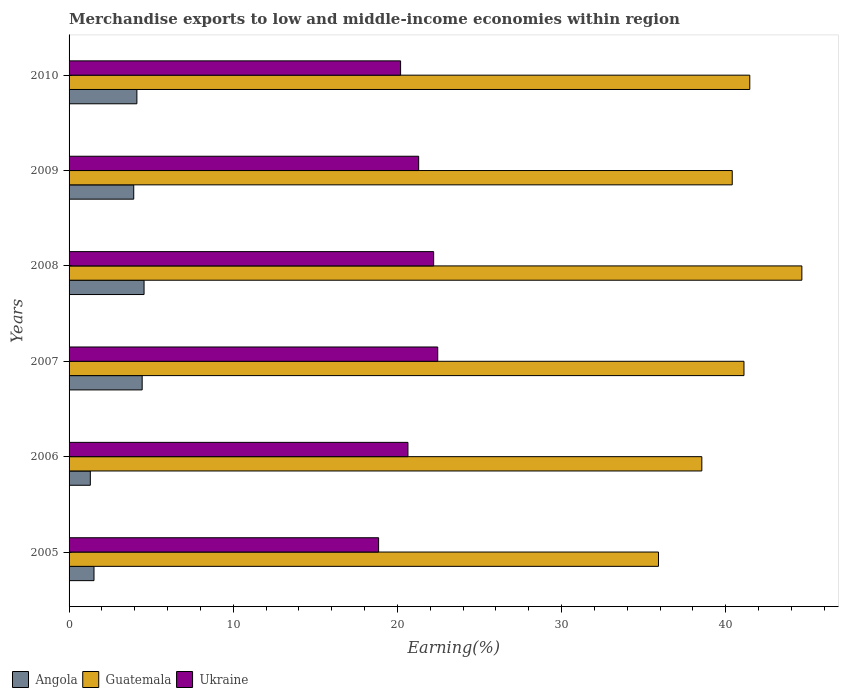Are the number of bars per tick equal to the number of legend labels?
Give a very brief answer. Yes. How many bars are there on the 3rd tick from the top?
Keep it short and to the point. 3. How many bars are there on the 2nd tick from the bottom?
Ensure brevity in your answer.  3. What is the label of the 2nd group of bars from the top?
Your answer should be very brief. 2009. What is the percentage of amount earned from merchandise exports in Angola in 2006?
Keep it short and to the point. 1.3. Across all years, what is the maximum percentage of amount earned from merchandise exports in Guatemala?
Give a very brief answer. 44.63. Across all years, what is the minimum percentage of amount earned from merchandise exports in Guatemala?
Provide a short and direct response. 35.9. In which year was the percentage of amount earned from merchandise exports in Angola maximum?
Your answer should be compact. 2008. In which year was the percentage of amount earned from merchandise exports in Angola minimum?
Ensure brevity in your answer.  2006. What is the total percentage of amount earned from merchandise exports in Guatemala in the graph?
Provide a succinct answer. 242.04. What is the difference between the percentage of amount earned from merchandise exports in Guatemala in 2005 and that in 2007?
Provide a succinct answer. -5.21. What is the difference between the percentage of amount earned from merchandise exports in Angola in 2006 and the percentage of amount earned from merchandise exports in Ukraine in 2009?
Provide a short and direct response. -20. What is the average percentage of amount earned from merchandise exports in Angola per year?
Ensure brevity in your answer.  3.32. In the year 2008, what is the difference between the percentage of amount earned from merchandise exports in Guatemala and percentage of amount earned from merchandise exports in Angola?
Your answer should be very brief. 40.07. What is the ratio of the percentage of amount earned from merchandise exports in Guatemala in 2005 to that in 2008?
Offer a terse response. 0.8. Is the percentage of amount earned from merchandise exports in Angola in 2007 less than that in 2010?
Offer a terse response. No. Is the difference between the percentage of amount earned from merchandise exports in Guatemala in 2005 and 2008 greater than the difference between the percentage of amount earned from merchandise exports in Angola in 2005 and 2008?
Offer a very short reply. No. What is the difference between the highest and the second highest percentage of amount earned from merchandise exports in Angola?
Offer a very short reply. 0.11. What is the difference between the highest and the lowest percentage of amount earned from merchandise exports in Ukraine?
Your answer should be very brief. 3.6. In how many years, is the percentage of amount earned from merchandise exports in Angola greater than the average percentage of amount earned from merchandise exports in Angola taken over all years?
Provide a succinct answer. 4. What does the 2nd bar from the top in 2008 represents?
Ensure brevity in your answer.  Guatemala. What does the 1st bar from the bottom in 2009 represents?
Make the answer very short. Angola. How many bars are there?
Your answer should be compact. 18. Are all the bars in the graph horizontal?
Your answer should be very brief. Yes. Does the graph contain any zero values?
Keep it short and to the point. No. Does the graph contain grids?
Offer a very short reply. No. Where does the legend appear in the graph?
Offer a very short reply. Bottom left. How are the legend labels stacked?
Your answer should be compact. Horizontal. What is the title of the graph?
Provide a short and direct response. Merchandise exports to low and middle-income economies within region. What is the label or title of the X-axis?
Your response must be concise. Earning(%). What is the Earning(%) in Angola in 2005?
Provide a succinct answer. 1.52. What is the Earning(%) of Guatemala in 2005?
Offer a very short reply. 35.9. What is the Earning(%) in Ukraine in 2005?
Your answer should be very brief. 18.85. What is the Earning(%) of Angola in 2006?
Provide a succinct answer. 1.3. What is the Earning(%) in Guatemala in 2006?
Make the answer very short. 38.54. What is the Earning(%) in Ukraine in 2006?
Your answer should be very brief. 20.64. What is the Earning(%) in Angola in 2007?
Your answer should be compact. 4.45. What is the Earning(%) of Guatemala in 2007?
Give a very brief answer. 41.11. What is the Earning(%) of Ukraine in 2007?
Offer a very short reply. 22.46. What is the Earning(%) in Angola in 2008?
Your answer should be compact. 4.57. What is the Earning(%) in Guatemala in 2008?
Offer a very short reply. 44.63. What is the Earning(%) in Ukraine in 2008?
Provide a short and direct response. 22.21. What is the Earning(%) in Angola in 2009?
Give a very brief answer. 3.94. What is the Earning(%) in Guatemala in 2009?
Offer a very short reply. 40.39. What is the Earning(%) in Ukraine in 2009?
Keep it short and to the point. 21.29. What is the Earning(%) in Angola in 2010?
Your response must be concise. 4.13. What is the Earning(%) of Guatemala in 2010?
Your response must be concise. 41.46. What is the Earning(%) in Ukraine in 2010?
Give a very brief answer. 20.19. Across all years, what is the maximum Earning(%) in Angola?
Keep it short and to the point. 4.57. Across all years, what is the maximum Earning(%) of Guatemala?
Provide a short and direct response. 44.63. Across all years, what is the maximum Earning(%) in Ukraine?
Ensure brevity in your answer.  22.46. Across all years, what is the minimum Earning(%) in Angola?
Provide a short and direct response. 1.3. Across all years, what is the minimum Earning(%) in Guatemala?
Your response must be concise. 35.9. Across all years, what is the minimum Earning(%) in Ukraine?
Your response must be concise. 18.85. What is the total Earning(%) of Angola in the graph?
Keep it short and to the point. 19.9. What is the total Earning(%) in Guatemala in the graph?
Offer a terse response. 242.03. What is the total Earning(%) of Ukraine in the graph?
Offer a very short reply. 125.64. What is the difference between the Earning(%) in Angola in 2005 and that in 2006?
Your answer should be very brief. 0.22. What is the difference between the Earning(%) in Guatemala in 2005 and that in 2006?
Your response must be concise. -2.64. What is the difference between the Earning(%) in Ukraine in 2005 and that in 2006?
Make the answer very short. -1.79. What is the difference between the Earning(%) of Angola in 2005 and that in 2007?
Offer a very short reply. -2.93. What is the difference between the Earning(%) in Guatemala in 2005 and that in 2007?
Your answer should be very brief. -5.21. What is the difference between the Earning(%) in Ukraine in 2005 and that in 2007?
Offer a terse response. -3.6. What is the difference between the Earning(%) in Angola in 2005 and that in 2008?
Make the answer very short. -3.05. What is the difference between the Earning(%) of Guatemala in 2005 and that in 2008?
Offer a terse response. -8.73. What is the difference between the Earning(%) in Ukraine in 2005 and that in 2008?
Provide a succinct answer. -3.35. What is the difference between the Earning(%) in Angola in 2005 and that in 2009?
Ensure brevity in your answer.  -2.42. What is the difference between the Earning(%) in Guatemala in 2005 and that in 2009?
Your response must be concise. -4.49. What is the difference between the Earning(%) in Ukraine in 2005 and that in 2009?
Your answer should be compact. -2.44. What is the difference between the Earning(%) in Angola in 2005 and that in 2010?
Make the answer very short. -2.61. What is the difference between the Earning(%) of Guatemala in 2005 and that in 2010?
Make the answer very short. -5.56. What is the difference between the Earning(%) of Ukraine in 2005 and that in 2010?
Ensure brevity in your answer.  -1.34. What is the difference between the Earning(%) in Angola in 2006 and that in 2007?
Provide a short and direct response. -3.16. What is the difference between the Earning(%) of Guatemala in 2006 and that in 2007?
Make the answer very short. -2.57. What is the difference between the Earning(%) of Ukraine in 2006 and that in 2007?
Provide a succinct answer. -1.81. What is the difference between the Earning(%) in Angola in 2006 and that in 2008?
Your response must be concise. -3.27. What is the difference between the Earning(%) in Guatemala in 2006 and that in 2008?
Make the answer very short. -6.09. What is the difference between the Earning(%) in Ukraine in 2006 and that in 2008?
Make the answer very short. -1.57. What is the difference between the Earning(%) of Angola in 2006 and that in 2009?
Provide a short and direct response. -2.64. What is the difference between the Earning(%) in Guatemala in 2006 and that in 2009?
Your response must be concise. -1.85. What is the difference between the Earning(%) of Ukraine in 2006 and that in 2009?
Your answer should be compact. -0.65. What is the difference between the Earning(%) in Angola in 2006 and that in 2010?
Make the answer very short. -2.84. What is the difference between the Earning(%) of Guatemala in 2006 and that in 2010?
Provide a short and direct response. -2.92. What is the difference between the Earning(%) in Ukraine in 2006 and that in 2010?
Keep it short and to the point. 0.45. What is the difference between the Earning(%) in Angola in 2007 and that in 2008?
Give a very brief answer. -0.11. What is the difference between the Earning(%) in Guatemala in 2007 and that in 2008?
Your answer should be very brief. -3.53. What is the difference between the Earning(%) of Ukraine in 2007 and that in 2008?
Provide a succinct answer. 0.25. What is the difference between the Earning(%) of Angola in 2007 and that in 2009?
Provide a short and direct response. 0.51. What is the difference between the Earning(%) of Guatemala in 2007 and that in 2009?
Make the answer very short. 0.71. What is the difference between the Earning(%) of Ukraine in 2007 and that in 2009?
Give a very brief answer. 1.16. What is the difference between the Earning(%) in Angola in 2007 and that in 2010?
Your response must be concise. 0.32. What is the difference between the Earning(%) of Guatemala in 2007 and that in 2010?
Give a very brief answer. -0.35. What is the difference between the Earning(%) in Ukraine in 2007 and that in 2010?
Provide a succinct answer. 2.26. What is the difference between the Earning(%) of Angola in 2008 and that in 2009?
Provide a succinct answer. 0.63. What is the difference between the Earning(%) of Guatemala in 2008 and that in 2009?
Keep it short and to the point. 4.24. What is the difference between the Earning(%) in Ukraine in 2008 and that in 2009?
Give a very brief answer. 0.91. What is the difference between the Earning(%) in Angola in 2008 and that in 2010?
Keep it short and to the point. 0.44. What is the difference between the Earning(%) in Guatemala in 2008 and that in 2010?
Keep it short and to the point. 3.17. What is the difference between the Earning(%) of Ukraine in 2008 and that in 2010?
Provide a succinct answer. 2.01. What is the difference between the Earning(%) in Angola in 2009 and that in 2010?
Your answer should be compact. -0.19. What is the difference between the Earning(%) in Guatemala in 2009 and that in 2010?
Give a very brief answer. -1.07. What is the difference between the Earning(%) in Ukraine in 2009 and that in 2010?
Your answer should be very brief. 1.1. What is the difference between the Earning(%) of Angola in 2005 and the Earning(%) of Guatemala in 2006?
Make the answer very short. -37.02. What is the difference between the Earning(%) of Angola in 2005 and the Earning(%) of Ukraine in 2006?
Ensure brevity in your answer.  -19.12. What is the difference between the Earning(%) in Guatemala in 2005 and the Earning(%) in Ukraine in 2006?
Your answer should be compact. 15.26. What is the difference between the Earning(%) in Angola in 2005 and the Earning(%) in Guatemala in 2007?
Provide a short and direct response. -39.59. What is the difference between the Earning(%) of Angola in 2005 and the Earning(%) of Ukraine in 2007?
Give a very brief answer. -20.94. What is the difference between the Earning(%) of Guatemala in 2005 and the Earning(%) of Ukraine in 2007?
Offer a very short reply. 13.45. What is the difference between the Earning(%) of Angola in 2005 and the Earning(%) of Guatemala in 2008?
Make the answer very short. -43.11. What is the difference between the Earning(%) in Angola in 2005 and the Earning(%) in Ukraine in 2008?
Offer a terse response. -20.69. What is the difference between the Earning(%) in Guatemala in 2005 and the Earning(%) in Ukraine in 2008?
Offer a very short reply. 13.69. What is the difference between the Earning(%) in Angola in 2005 and the Earning(%) in Guatemala in 2009?
Ensure brevity in your answer.  -38.87. What is the difference between the Earning(%) of Angola in 2005 and the Earning(%) of Ukraine in 2009?
Your answer should be very brief. -19.78. What is the difference between the Earning(%) in Guatemala in 2005 and the Earning(%) in Ukraine in 2009?
Offer a very short reply. 14.61. What is the difference between the Earning(%) of Angola in 2005 and the Earning(%) of Guatemala in 2010?
Provide a succinct answer. -39.94. What is the difference between the Earning(%) of Angola in 2005 and the Earning(%) of Ukraine in 2010?
Keep it short and to the point. -18.67. What is the difference between the Earning(%) of Guatemala in 2005 and the Earning(%) of Ukraine in 2010?
Provide a short and direct response. 15.71. What is the difference between the Earning(%) of Angola in 2006 and the Earning(%) of Guatemala in 2007?
Your answer should be very brief. -39.81. What is the difference between the Earning(%) in Angola in 2006 and the Earning(%) in Ukraine in 2007?
Offer a very short reply. -21.16. What is the difference between the Earning(%) in Guatemala in 2006 and the Earning(%) in Ukraine in 2007?
Provide a short and direct response. 16.09. What is the difference between the Earning(%) of Angola in 2006 and the Earning(%) of Guatemala in 2008?
Keep it short and to the point. -43.34. What is the difference between the Earning(%) in Angola in 2006 and the Earning(%) in Ukraine in 2008?
Offer a very short reply. -20.91. What is the difference between the Earning(%) in Guatemala in 2006 and the Earning(%) in Ukraine in 2008?
Make the answer very short. 16.33. What is the difference between the Earning(%) of Angola in 2006 and the Earning(%) of Guatemala in 2009?
Your answer should be very brief. -39.1. What is the difference between the Earning(%) of Angola in 2006 and the Earning(%) of Ukraine in 2009?
Provide a short and direct response. -20. What is the difference between the Earning(%) of Guatemala in 2006 and the Earning(%) of Ukraine in 2009?
Your response must be concise. 17.25. What is the difference between the Earning(%) in Angola in 2006 and the Earning(%) in Guatemala in 2010?
Offer a terse response. -40.17. What is the difference between the Earning(%) in Angola in 2006 and the Earning(%) in Ukraine in 2010?
Make the answer very short. -18.9. What is the difference between the Earning(%) of Guatemala in 2006 and the Earning(%) of Ukraine in 2010?
Provide a succinct answer. 18.35. What is the difference between the Earning(%) in Angola in 2007 and the Earning(%) in Guatemala in 2008?
Provide a short and direct response. -40.18. What is the difference between the Earning(%) of Angola in 2007 and the Earning(%) of Ukraine in 2008?
Provide a succinct answer. -17.75. What is the difference between the Earning(%) of Guatemala in 2007 and the Earning(%) of Ukraine in 2008?
Make the answer very short. 18.9. What is the difference between the Earning(%) in Angola in 2007 and the Earning(%) in Guatemala in 2009?
Keep it short and to the point. -35.94. What is the difference between the Earning(%) in Angola in 2007 and the Earning(%) in Ukraine in 2009?
Provide a short and direct response. -16.84. What is the difference between the Earning(%) in Guatemala in 2007 and the Earning(%) in Ukraine in 2009?
Provide a succinct answer. 19.81. What is the difference between the Earning(%) in Angola in 2007 and the Earning(%) in Guatemala in 2010?
Your response must be concise. -37.01. What is the difference between the Earning(%) of Angola in 2007 and the Earning(%) of Ukraine in 2010?
Provide a short and direct response. -15.74. What is the difference between the Earning(%) of Guatemala in 2007 and the Earning(%) of Ukraine in 2010?
Ensure brevity in your answer.  20.91. What is the difference between the Earning(%) in Angola in 2008 and the Earning(%) in Guatemala in 2009?
Offer a terse response. -35.83. What is the difference between the Earning(%) of Angola in 2008 and the Earning(%) of Ukraine in 2009?
Your response must be concise. -16.73. What is the difference between the Earning(%) in Guatemala in 2008 and the Earning(%) in Ukraine in 2009?
Give a very brief answer. 23.34. What is the difference between the Earning(%) of Angola in 2008 and the Earning(%) of Guatemala in 2010?
Your answer should be compact. -36.89. What is the difference between the Earning(%) in Angola in 2008 and the Earning(%) in Ukraine in 2010?
Give a very brief answer. -15.63. What is the difference between the Earning(%) of Guatemala in 2008 and the Earning(%) of Ukraine in 2010?
Offer a terse response. 24.44. What is the difference between the Earning(%) of Angola in 2009 and the Earning(%) of Guatemala in 2010?
Your response must be concise. -37.52. What is the difference between the Earning(%) in Angola in 2009 and the Earning(%) in Ukraine in 2010?
Provide a succinct answer. -16.25. What is the difference between the Earning(%) in Guatemala in 2009 and the Earning(%) in Ukraine in 2010?
Make the answer very short. 20.2. What is the average Earning(%) in Angola per year?
Ensure brevity in your answer.  3.32. What is the average Earning(%) of Guatemala per year?
Provide a short and direct response. 40.34. What is the average Earning(%) in Ukraine per year?
Ensure brevity in your answer.  20.94. In the year 2005, what is the difference between the Earning(%) in Angola and Earning(%) in Guatemala?
Offer a very short reply. -34.38. In the year 2005, what is the difference between the Earning(%) of Angola and Earning(%) of Ukraine?
Ensure brevity in your answer.  -17.34. In the year 2005, what is the difference between the Earning(%) in Guatemala and Earning(%) in Ukraine?
Offer a very short reply. 17.05. In the year 2006, what is the difference between the Earning(%) of Angola and Earning(%) of Guatemala?
Offer a terse response. -37.25. In the year 2006, what is the difference between the Earning(%) in Angola and Earning(%) in Ukraine?
Keep it short and to the point. -19.35. In the year 2006, what is the difference between the Earning(%) of Guatemala and Earning(%) of Ukraine?
Give a very brief answer. 17.9. In the year 2007, what is the difference between the Earning(%) in Angola and Earning(%) in Guatemala?
Your answer should be very brief. -36.65. In the year 2007, what is the difference between the Earning(%) in Angola and Earning(%) in Ukraine?
Your answer should be compact. -18. In the year 2007, what is the difference between the Earning(%) in Guatemala and Earning(%) in Ukraine?
Ensure brevity in your answer.  18.65. In the year 2008, what is the difference between the Earning(%) in Angola and Earning(%) in Guatemala?
Offer a very short reply. -40.07. In the year 2008, what is the difference between the Earning(%) of Angola and Earning(%) of Ukraine?
Provide a short and direct response. -17.64. In the year 2008, what is the difference between the Earning(%) of Guatemala and Earning(%) of Ukraine?
Provide a short and direct response. 22.43. In the year 2009, what is the difference between the Earning(%) of Angola and Earning(%) of Guatemala?
Offer a terse response. -36.45. In the year 2009, what is the difference between the Earning(%) in Angola and Earning(%) in Ukraine?
Ensure brevity in your answer.  -17.36. In the year 2009, what is the difference between the Earning(%) of Guatemala and Earning(%) of Ukraine?
Offer a very short reply. 19.1. In the year 2010, what is the difference between the Earning(%) in Angola and Earning(%) in Guatemala?
Provide a short and direct response. -37.33. In the year 2010, what is the difference between the Earning(%) in Angola and Earning(%) in Ukraine?
Your response must be concise. -16.06. In the year 2010, what is the difference between the Earning(%) of Guatemala and Earning(%) of Ukraine?
Your response must be concise. 21.27. What is the ratio of the Earning(%) in Angola in 2005 to that in 2006?
Offer a terse response. 1.17. What is the ratio of the Earning(%) of Guatemala in 2005 to that in 2006?
Give a very brief answer. 0.93. What is the ratio of the Earning(%) of Ukraine in 2005 to that in 2006?
Offer a terse response. 0.91. What is the ratio of the Earning(%) in Angola in 2005 to that in 2007?
Ensure brevity in your answer.  0.34. What is the ratio of the Earning(%) in Guatemala in 2005 to that in 2007?
Ensure brevity in your answer.  0.87. What is the ratio of the Earning(%) in Ukraine in 2005 to that in 2007?
Offer a very short reply. 0.84. What is the ratio of the Earning(%) of Angola in 2005 to that in 2008?
Keep it short and to the point. 0.33. What is the ratio of the Earning(%) of Guatemala in 2005 to that in 2008?
Offer a terse response. 0.8. What is the ratio of the Earning(%) of Ukraine in 2005 to that in 2008?
Provide a short and direct response. 0.85. What is the ratio of the Earning(%) of Angola in 2005 to that in 2009?
Provide a short and direct response. 0.39. What is the ratio of the Earning(%) in Guatemala in 2005 to that in 2009?
Your answer should be compact. 0.89. What is the ratio of the Earning(%) of Ukraine in 2005 to that in 2009?
Give a very brief answer. 0.89. What is the ratio of the Earning(%) in Angola in 2005 to that in 2010?
Offer a very short reply. 0.37. What is the ratio of the Earning(%) in Guatemala in 2005 to that in 2010?
Provide a succinct answer. 0.87. What is the ratio of the Earning(%) in Ukraine in 2005 to that in 2010?
Make the answer very short. 0.93. What is the ratio of the Earning(%) of Angola in 2006 to that in 2007?
Give a very brief answer. 0.29. What is the ratio of the Earning(%) in Guatemala in 2006 to that in 2007?
Offer a terse response. 0.94. What is the ratio of the Earning(%) in Ukraine in 2006 to that in 2007?
Keep it short and to the point. 0.92. What is the ratio of the Earning(%) of Angola in 2006 to that in 2008?
Your response must be concise. 0.28. What is the ratio of the Earning(%) in Guatemala in 2006 to that in 2008?
Provide a succinct answer. 0.86. What is the ratio of the Earning(%) in Ukraine in 2006 to that in 2008?
Offer a very short reply. 0.93. What is the ratio of the Earning(%) of Angola in 2006 to that in 2009?
Provide a short and direct response. 0.33. What is the ratio of the Earning(%) in Guatemala in 2006 to that in 2009?
Your response must be concise. 0.95. What is the ratio of the Earning(%) in Ukraine in 2006 to that in 2009?
Provide a short and direct response. 0.97. What is the ratio of the Earning(%) in Angola in 2006 to that in 2010?
Offer a very short reply. 0.31. What is the ratio of the Earning(%) of Guatemala in 2006 to that in 2010?
Offer a terse response. 0.93. What is the ratio of the Earning(%) in Ukraine in 2006 to that in 2010?
Your answer should be very brief. 1.02. What is the ratio of the Earning(%) of Angola in 2007 to that in 2008?
Offer a very short reply. 0.97. What is the ratio of the Earning(%) in Guatemala in 2007 to that in 2008?
Your response must be concise. 0.92. What is the ratio of the Earning(%) in Ukraine in 2007 to that in 2008?
Provide a succinct answer. 1.01. What is the ratio of the Earning(%) of Angola in 2007 to that in 2009?
Give a very brief answer. 1.13. What is the ratio of the Earning(%) in Guatemala in 2007 to that in 2009?
Offer a terse response. 1.02. What is the ratio of the Earning(%) of Ukraine in 2007 to that in 2009?
Your response must be concise. 1.05. What is the ratio of the Earning(%) in Angola in 2007 to that in 2010?
Provide a short and direct response. 1.08. What is the ratio of the Earning(%) in Guatemala in 2007 to that in 2010?
Offer a terse response. 0.99. What is the ratio of the Earning(%) of Ukraine in 2007 to that in 2010?
Your response must be concise. 1.11. What is the ratio of the Earning(%) in Angola in 2008 to that in 2009?
Make the answer very short. 1.16. What is the ratio of the Earning(%) in Guatemala in 2008 to that in 2009?
Your response must be concise. 1.1. What is the ratio of the Earning(%) of Ukraine in 2008 to that in 2009?
Your answer should be very brief. 1.04. What is the ratio of the Earning(%) of Angola in 2008 to that in 2010?
Your response must be concise. 1.11. What is the ratio of the Earning(%) in Guatemala in 2008 to that in 2010?
Keep it short and to the point. 1.08. What is the ratio of the Earning(%) in Ukraine in 2008 to that in 2010?
Keep it short and to the point. 1.1. What is the ratio of the Earning(%) in Angola in 2009 to that in 2010?
Make the answer very short. 0.95. What is the ratio of the Earning(%) in Guatemala in 2009 to that in 2010?
Make the answer very short. 0.97. What is the ratio of the Earning(%) in Ukraine in 2009 to that in 2010?
Your answer should be very brief. 1.05. What is the difference between the highest and the second highest Earning(%) in Angola?
Give a very brief answer. 0.11. What is the difference between the highest and the second highest Earning(%) in Guatemala?
Provide a short and direct response. 3.17. What is the difference between the highest and the second highest Earning(%) of Ukraine?
Ensure brevity in your answer.  0.25. What is the difference between the highest and the lowest Earning(%) of Angola?
Keep it short and to the point. 3.27. What is the difference between the highest and the lowest Earning(%) in Guatemala?
Provide a short and direct response. 8.73. What is the difference between the highest and the lowest Earning(%) in Ukraine?
Your answer should be very brief. 3.6. 